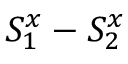<formula> <loc_0><loc_0><loc_500><loc_500>S _ { 1 } ^ { x } - S _ { 2 } ^ { x }</formula> 